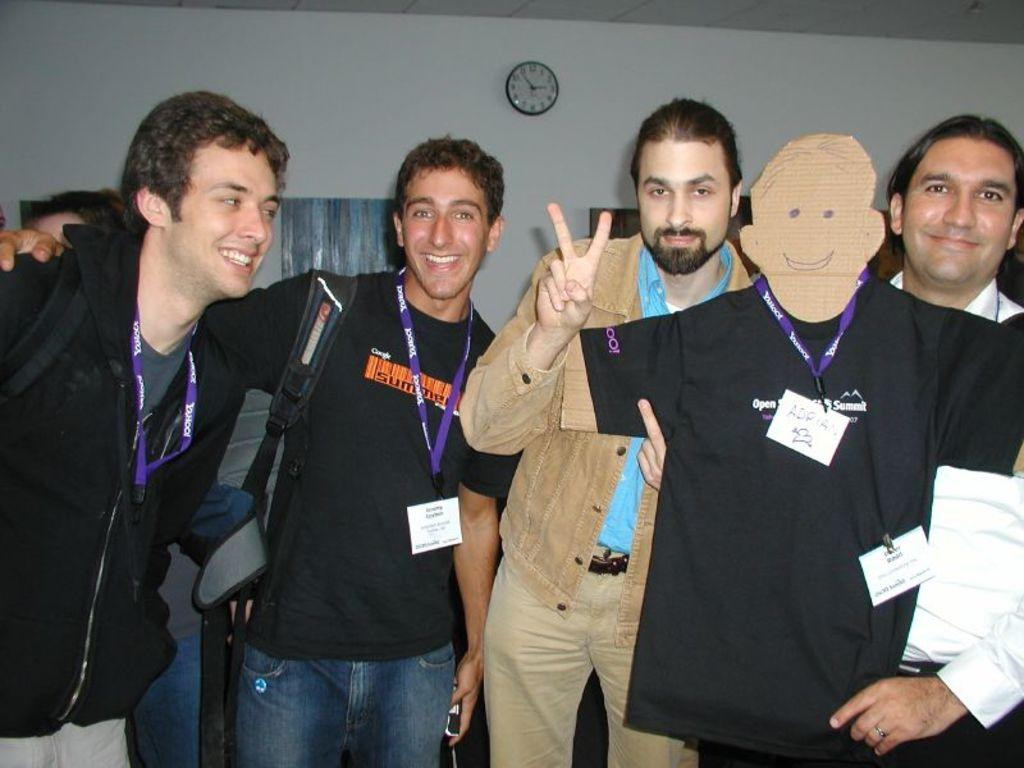How many men are in the image? There are four men in the image. What are the men doing in the image? The men are standing and smiling. Can you describe the attire of one of the men? One of the men has a badge and a T-shirt. What object can be seen attached to the wall in the image? There is a wall clock attached to the wall. Is the image presented in a specific format? The image may be framed. What type of bears can be seen wearing copper veils in the image? There are no bears or veils present in the image; it features four men standing and smiling. 